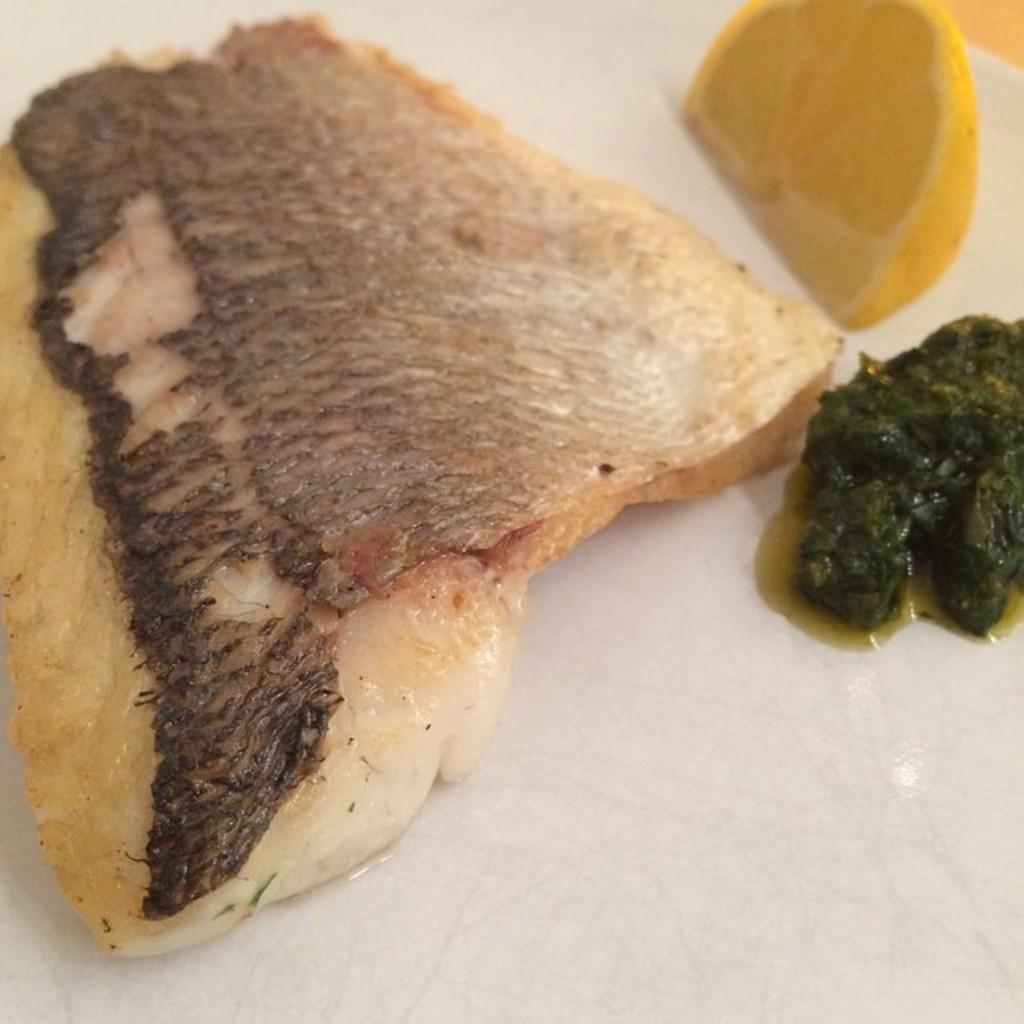Describe this image in one or two sentences. In this image, we can see some food items and lemon slice are placed on the white surface. 